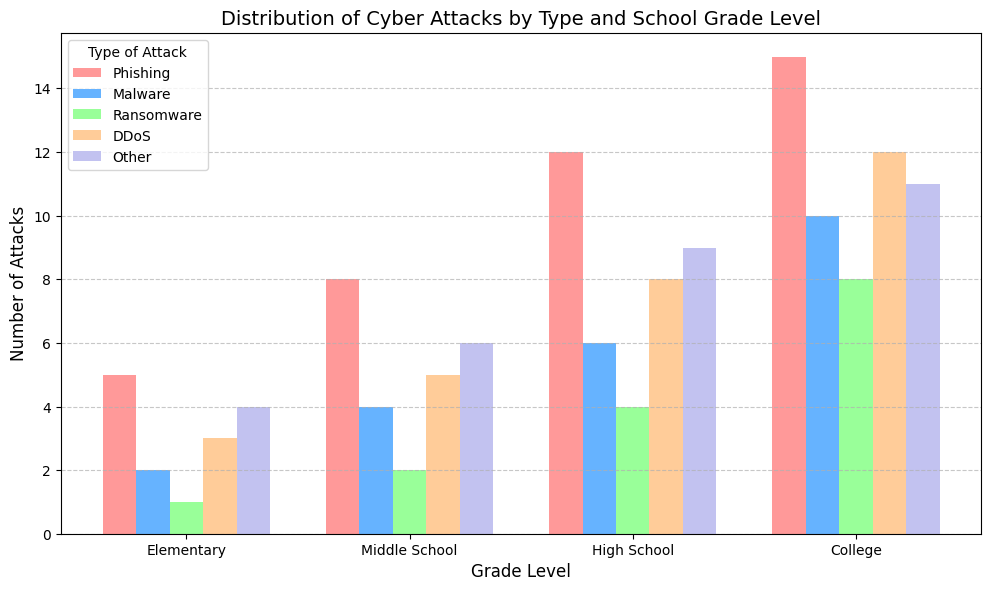what is the most common type of cyber attack in elementary schools? By looking at the tallest bar in the Elementary group, we can identify which type has the highest number. The "Phishing" bar is the tallest.
Answer: Phishing Which grade level has the highest number of DDoS attacks? By comparing the heights of the DDoS bars across all grade levels, the bar for "College" is the tallest.
Answer: College what is the total number of ransomware attacks across all grade levels? Adding up the height values of the ransomware bars for each grade level: 1 (Elementary) + 2 (Middle School) + 4 (High School) + 8 (College).
Answer: 15 Between Middle School and High School, which has a higher number of malware attacks? By comparing the heights of the malware bars: Middle School's is 4, and High School's is 6.
Answer: High School how many more phishing attacks are there in high schools compared to middle schools? Subtract the number of phishing attacks in Middle School (8) from High School (12).
Answer: 4 how many fewer other attacks are there in elementary schools compared to colleges? Subtract the number of other attacks in Elementary (4) from College (11).
Answer: 7 What is the average number of cyber attacks on colleges for the given types? Sum all the attack types for College (15+10+8+12+11) and divide by the number of types (5).
Answer: 11.2 Which type of attack has the most significant increase from High School to College? Calculate the difference for each type of attack between High School and College, and identify the maximum difference: Phishing (3), Malware (4), Ransomware (4), DDoS (4), Other (2).
Answer: Malware, Ransomware, DDoS What is the combined total of 'Other' attacks in elementary and middle schools? Add the number of Other attacks in Elementary (4) and Middle School (6).
Answer: 10 